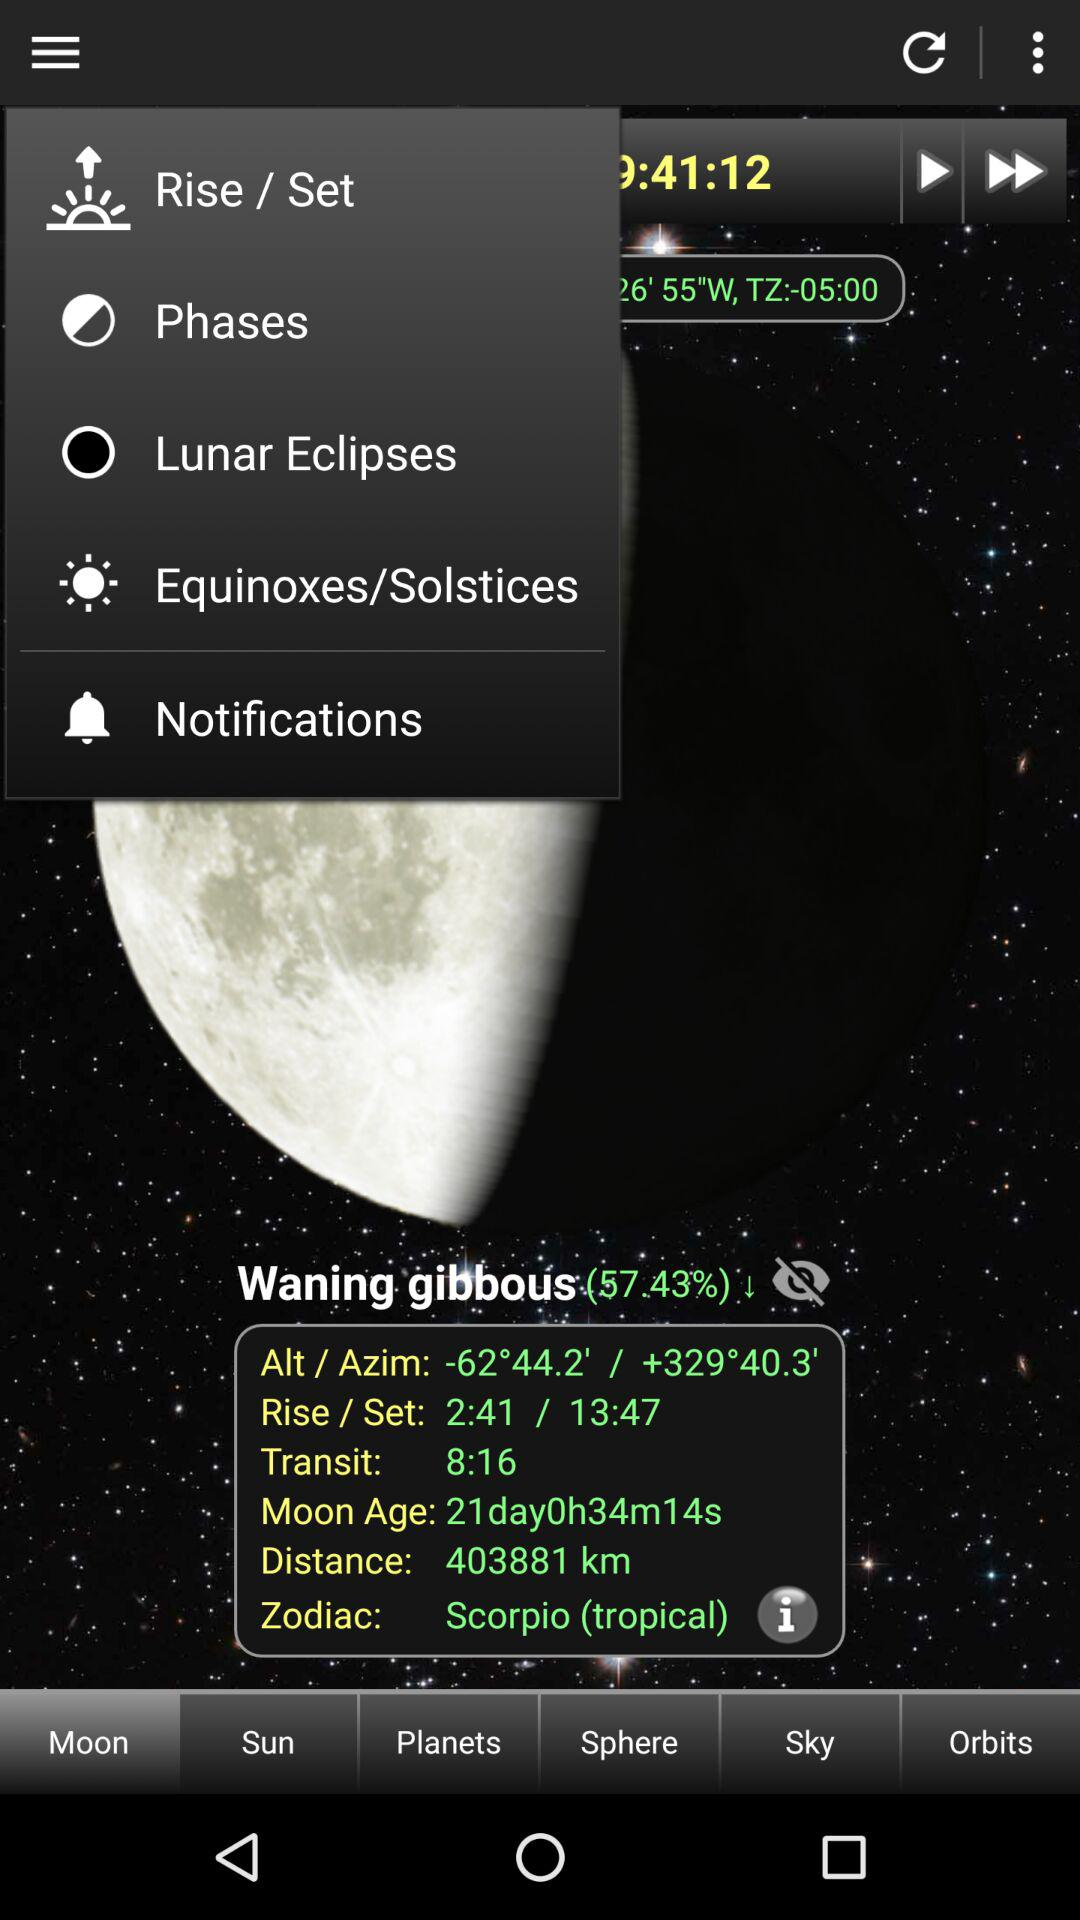When is the next full moon?
When the provided information is insufficient, respond with <no answer>. <no answer> 